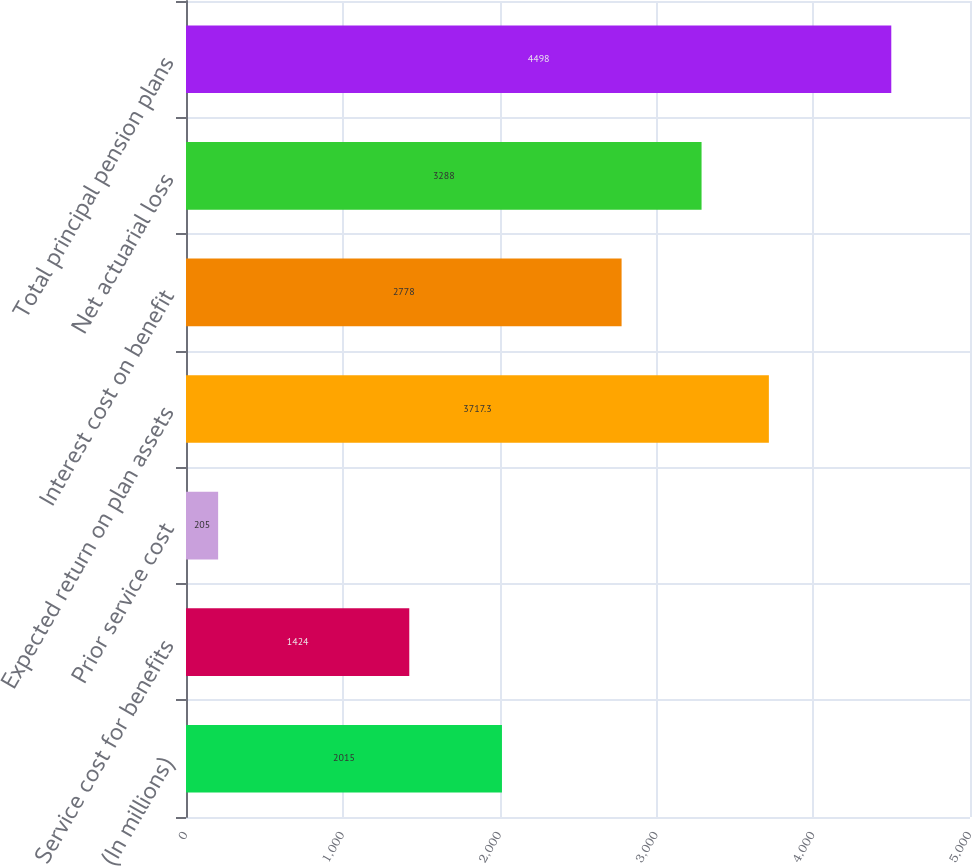<chart> <loc_0><loc_0><loc_500><loc_500><bar_chart><fcel>(In millions)<fcel>Service cost for benefits<fcel>Prior service cost<fcel>Expected return on plan assets<fcel>Interest cost on benefit<fcel>Net actuarial loss<fcel>Total principal pension plans<nl><fcel>2015<fcel>1424<fcel>205<fcel>3717.3<fcel>2778<fcel>3288<fcel>4498<nl></chart> 